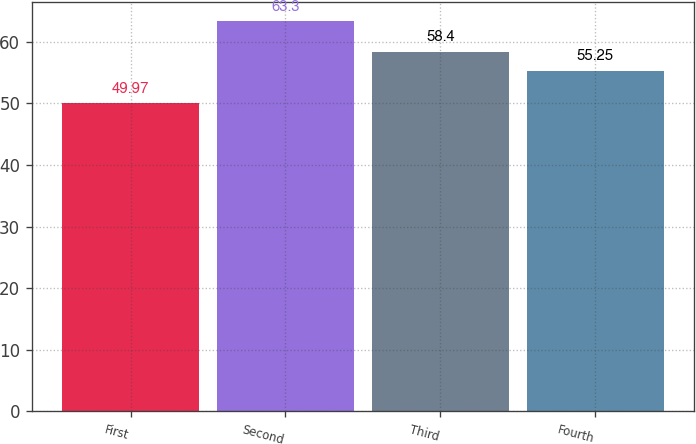<chart> <loc_0><loc_0><loc_500><loc_500><bar_chart><fcel>First<fcel>Second<fcel>Third<fcel>Fourth<nl><fcel>49.97<fcel>63.3<fcel>58.4<fcel>55.25<nl></chart> 